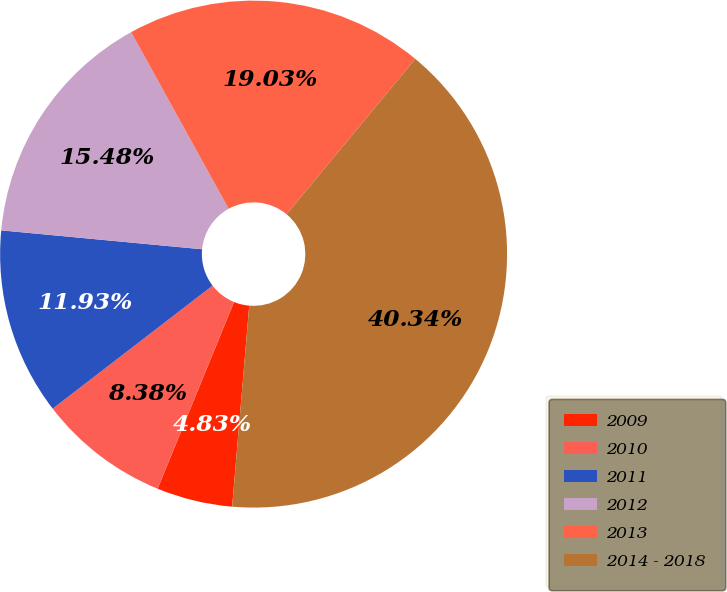<chart> <loc_0><loc_0><loc_500><loc_500><pie_chart><fcel>2009<fcel>2010<fcel>2011<fcel>2012<fcel>2013<fcel>2014 - 2018<nl><fcel>4.83%<fcel>8.38%<fcel>11.93%<fcel>15.48%<fcel>19.03%<fcel>40.33%<nl></chart> 